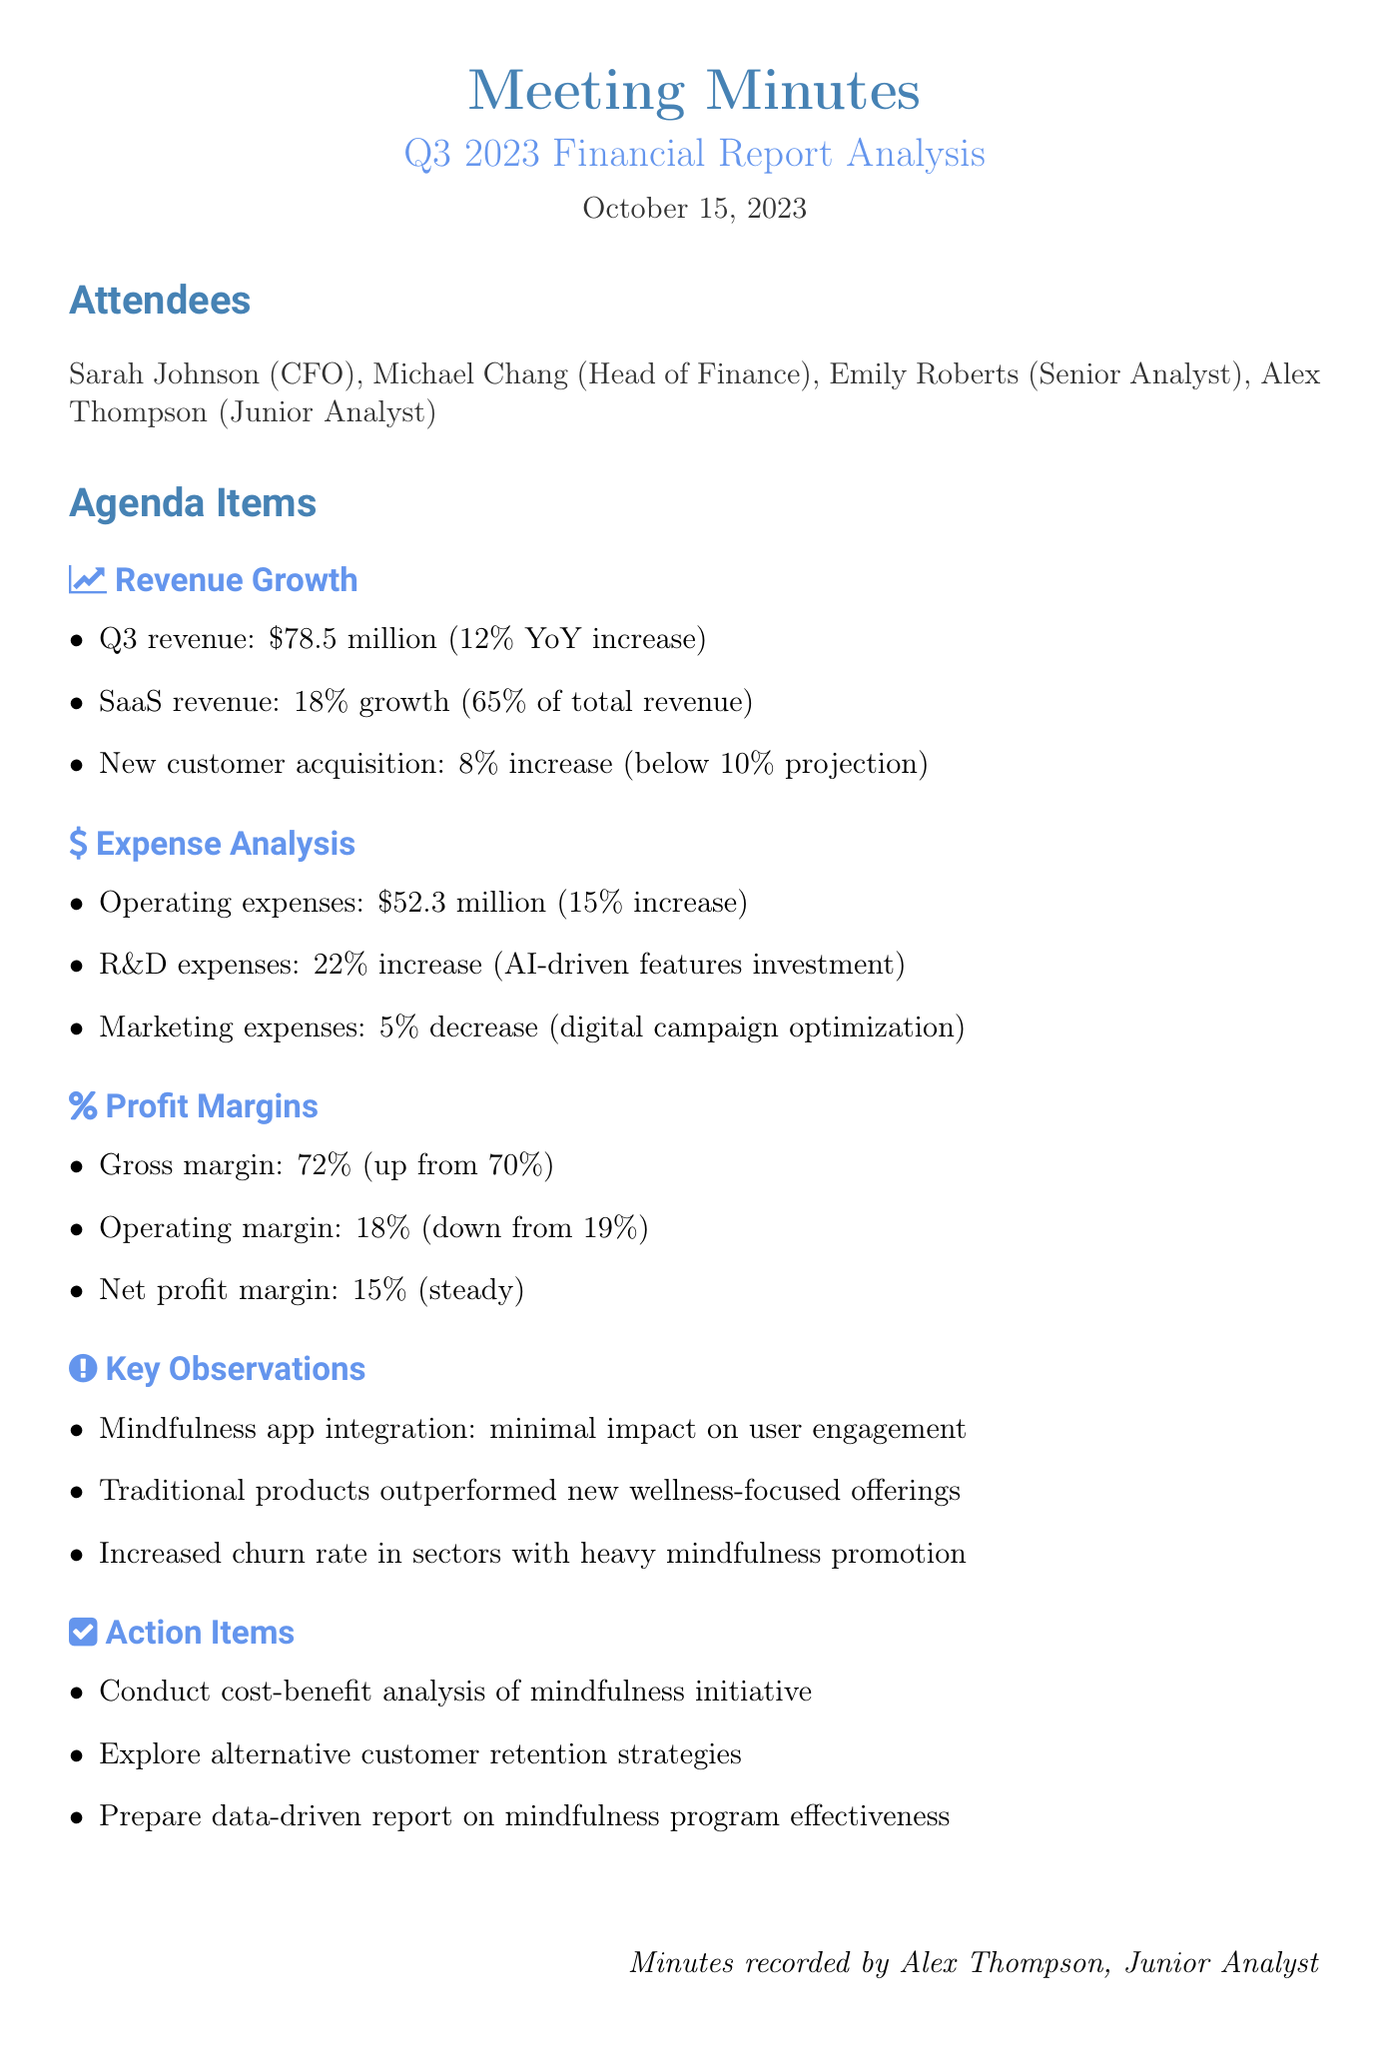What was the total revenue for Q3 2023? The total revenue for Q3 2023 is mentioned specifically in the document, which is $78.5 million.
Answer: $78.5 million What percentage did SaaS revenue grow in Q3? The document states that SaaS revenue grew by 18% in Q3.
Answer: 18% What was the increase in new customer acquisition? New customer acquisition is specified to have increased by 8% in the document.
Answer: 8% How much did operating expenses increase by? The document indicates that operating expenses increased by 15%.
Answer: 15% What was the gross margin in the previous quarter? The previous gross margin was 70%, as stated in the document.
Answer: 70% What was the net profit margin in Q3 2023? The document states that the net profit margin held steady at 15%.
Answer: 15% What key observation was made about the mindfulness app integration? It was noted that the mindfulness app integration showed minimal impact on user engagement metrics.
Answer: Minimal impact What action item involves the mindfulness initiative? The document lists conducting a cost-benefit analysis of the mindfulness initiative as an action item.
Answer: Cost-benefit analysis Which type of offerings outperformed the newer products? Traditional product lines are mentioned to have outperformed newer 'wellness-focused' offerings.
Answer: Traditional product lines 